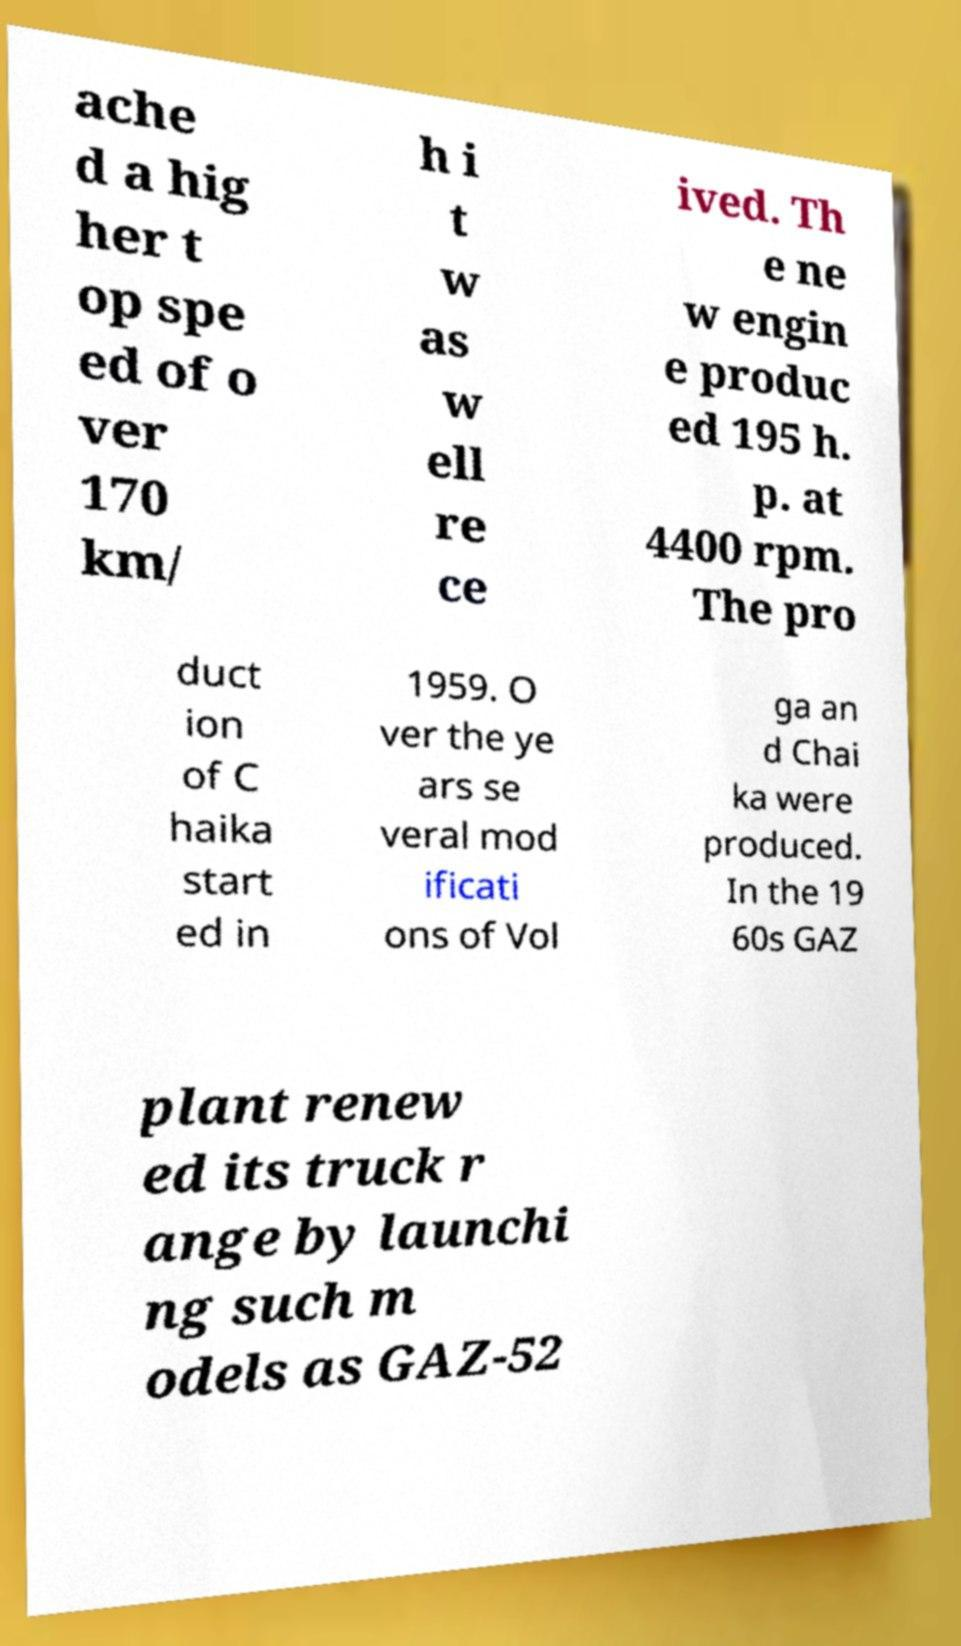For documentation purposes, I need the text within this image transcribed. Could you provide that? ache d a hig her t op spe ed of o ver 170 km/ h i t w as w ell re ce ived. Th e ne w engin e produc ed 195 h. p. at 4400 rpm. The pro duct ion of C haika start ed in 1959. O ver the ye ars se veral mod ificati ons of Vol ga an d Chai ka were produced. In the 19 60s GAZ plant renew ed its truck r ange by launchi ng such m odels as GAZ-52 